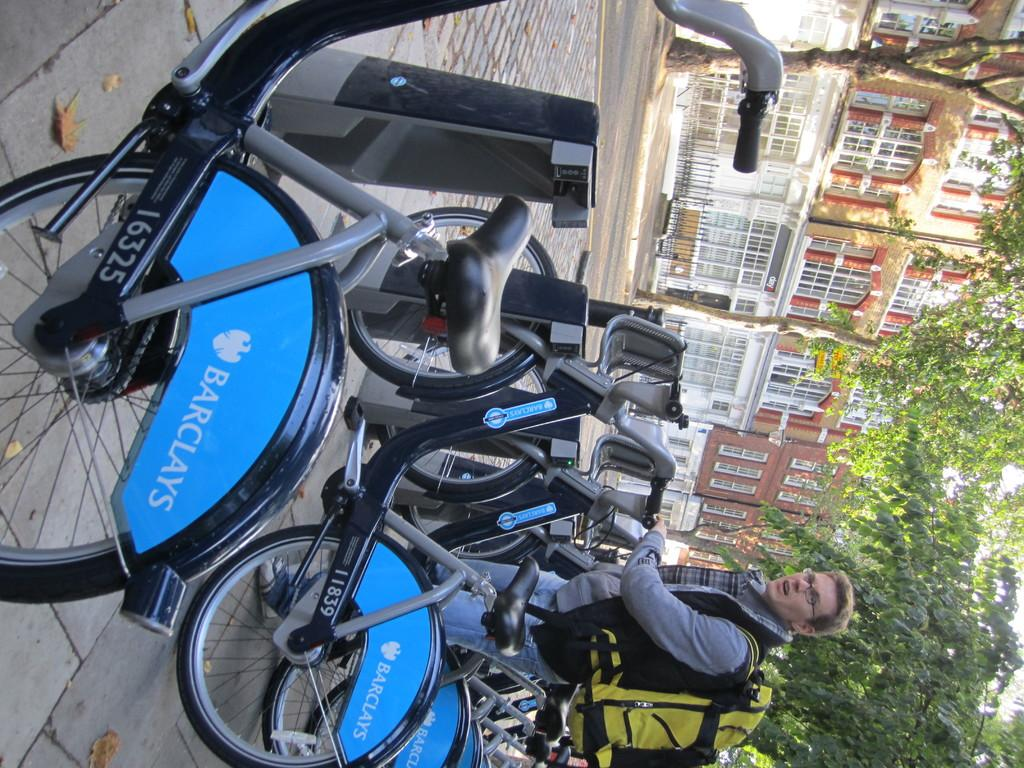What can be seen parked on the road in the image? There are multiple bicycles parked on the road. What is the person standing nearby wearing? The person is wearing a backpack. What type of natural elements can be seen in the image? There are trees visible in the image. What type of man-made structures can be seen in the image? There is at least one building in the image. What type of egg is being used as a prop in the image? There is no egg present in the image. What type of apparel is the person wearing on their feet? The provided facts do not mention the person's footwear, so it cannot be determined from the image. 